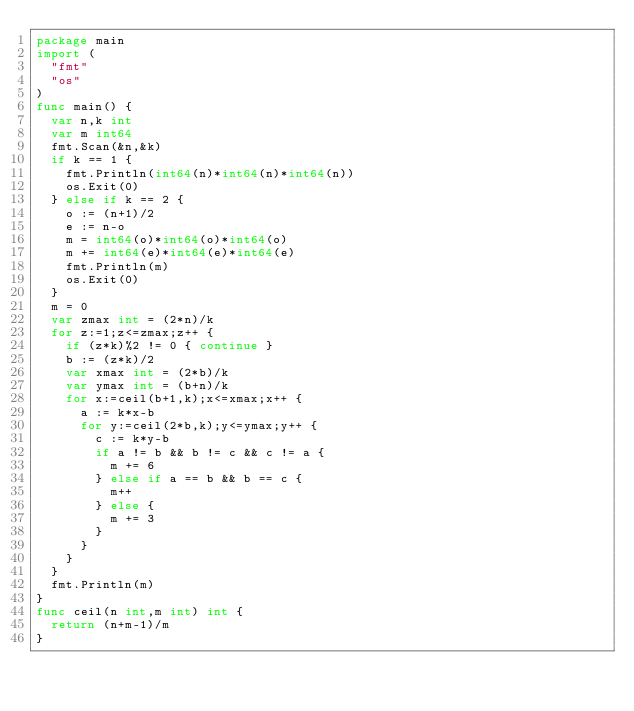Convert code to text. <code><loc_0><loc_0><loc_500><loc_500><_Go_>package main
import (
  "fmt"
  "os"
)
func main() {
  var n,k int
  var m int64
  fmt.Scan(&n,&k)
  if k == 1 {
    fmt.Println(int64(n)*int64(n)*int64(n))
    os.Exit(0)
  } else if k == 2 {
    o := (n+1)/2
    e := n-o
    m = int64(o)*int64(o)*int64(o)
    m += int64(e)*int64(e)*int64(e)
    fmt.Println(m)
    os.Exit(0)
  }
  m = 0
  var zmax int = (2*n)/k
  for z:=1;z<=zmax;z++ {
    if (z*k)%2 != 0 { continue }
    b := (z*k)/2
    var xmax int = (2*b)/k
    var ymax int = (b+n)/k
    for x:=ceil(b+1,k);x<=xmax;x++ {
      a := k*x-b
      for y:=ceil(2*b,k);y<=ymax;y++ {
        c := k*y-b
        if a != b && b != c && c != a {
          m += 6
        } else if a == b && b == c {
          m++
        } else {
          m += 3
        }
      }
    }
  }
  fmt.Println(m)
}
func ceil(n int,m int) int {
  return (n+m-1)/m
}</code> 